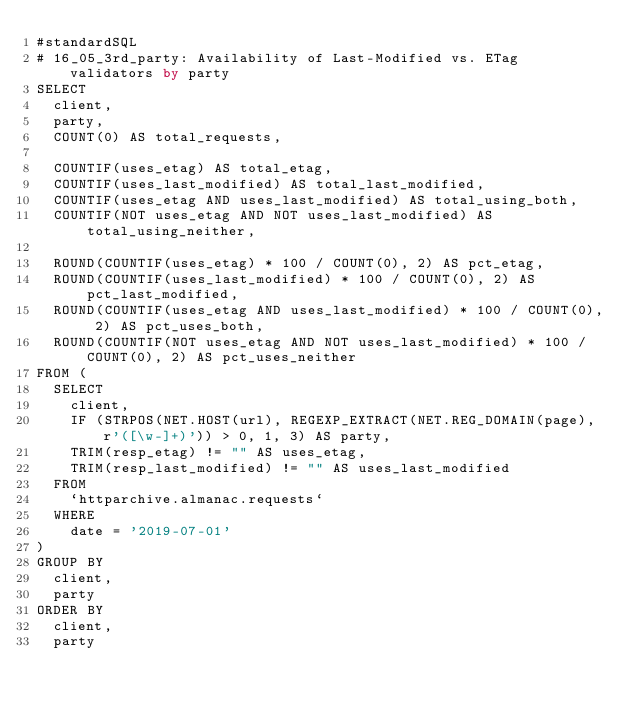<code> <loc_0><loc_0><loc_500><loc_500><_SQL_>#standardSQL
# 16_05_3rd_party: Availability of Last-Modified vs. ETag validators by party
SELECT
  client,
  party,
  COUNT(0) AS total_requests,

  COUNTIF(uses_etag) AS total_etag,
  COUNTIF(uses_last_modified) AS total_last_modified,
  COUNTIF(uses_etag AND uses_last_modified) AS total_using_both,
  COUNTIF(NOT uses_etag AND NOT uses_last_modified) AS total_using_neither,

  ROUND(COUNTIF(uses_etag) * 100 / COUNT(0), 2) AS pct_etag,
  ROUND(COUNTIF(uses_last_modified) * 100 / COUNT(0), 2) AS pct_last_modified,
  ROUND(COUNTIF(uses_etag AND uses_last_modified) * 100 / COUNT(0), 2) AS pct_uses_both,
  ROUND(COUNTIF(NOT uses_etag AND NOT uses_last_modified) * 100 / COUNT(0), 2) AS pct_uses_neither
FROM (
  SELECT
    client,
    IF (STRPOS(NET.HOST(url), REGEXP_EXTRACT(NET.REG_DOMAIN(page), r'([\w-]+)')) > 0, 1, 3) AS party,
    TRIM(resp_etag) != "" AS uses_etag,
    TRIM(resp_last_modified) != "" AS uses_last_modified
  FROM
    `httparchive.almanac.requests`
  WHERE
    date = '2019-07-01'
)
GROUP BY
  client,
  party
ORDER BY
  client,
  party
</code> 